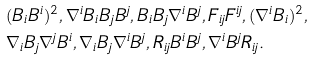<formula> <loc_0><loc_0><loc_500><loc_500>& ( B _ { i } B ^ { i } ) ^ { 2 } , \nabla ^ { i } B _ { i } B _ { j } B ^ { j } , B _ { i } B _ { j } \nabla ^ { i } B ^ { j } , F _ { i j } F ^ { i j } , ( \nabla ^ { i } B _ { i } ) ^ { 2 } , \\ & \nabla _ { i } B _ { j } \nabla ^ { j } B ^ { i } , \nabla _ { i } B _ { j } \nabla ^ { i } B ^ { j } , R _ { i j } B ^ { i } B ^ { j } , \nabla ^ { i } B ^ { j } R _ { i j } .</formula> 